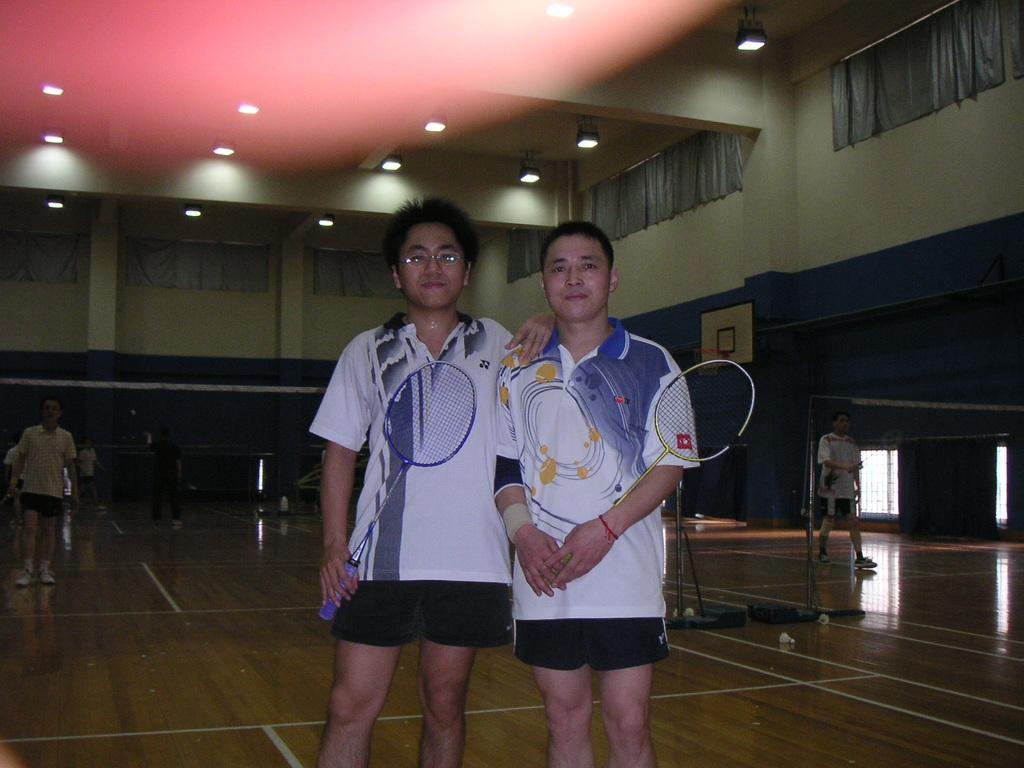How would you summarize this image in a sentence or two? In the center of the image we can see two mans are standing and holding racket in their hand. In the background of the image we can see some persons, mesh, volleyball coat, wall, curtains. At the top of the image we can see roof and lights. At the bottom of the image we can see the floor. On the right side of the image we can see the windows. 